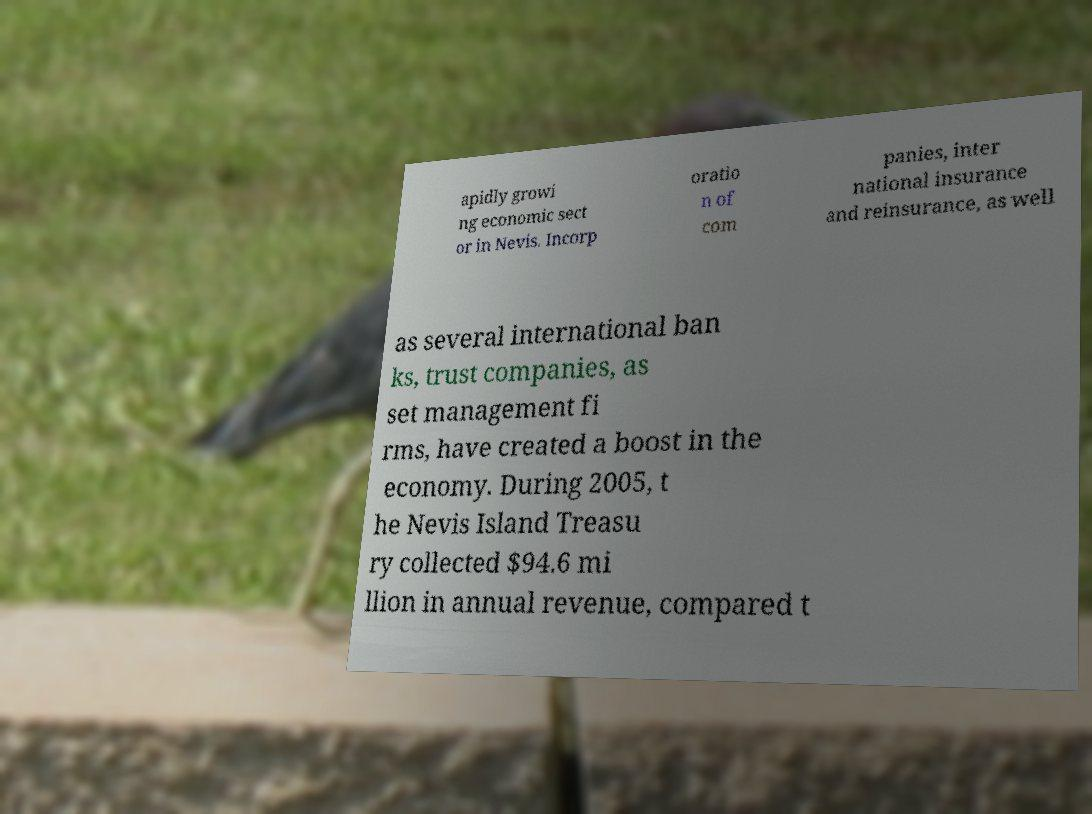I need the written content from this picture converted into text. Can you do that? apidly growi ng economic sect or in Nevis. Incorp oratio n of com panies, inter national insurance and reinsurance, as well as several international ban ks, trust companies, as set management fi rms, have created a boost in the economy. During 2005, t he Nevis Island Treasu ry collected $94.6 mi llion in annual revenue, compared t 